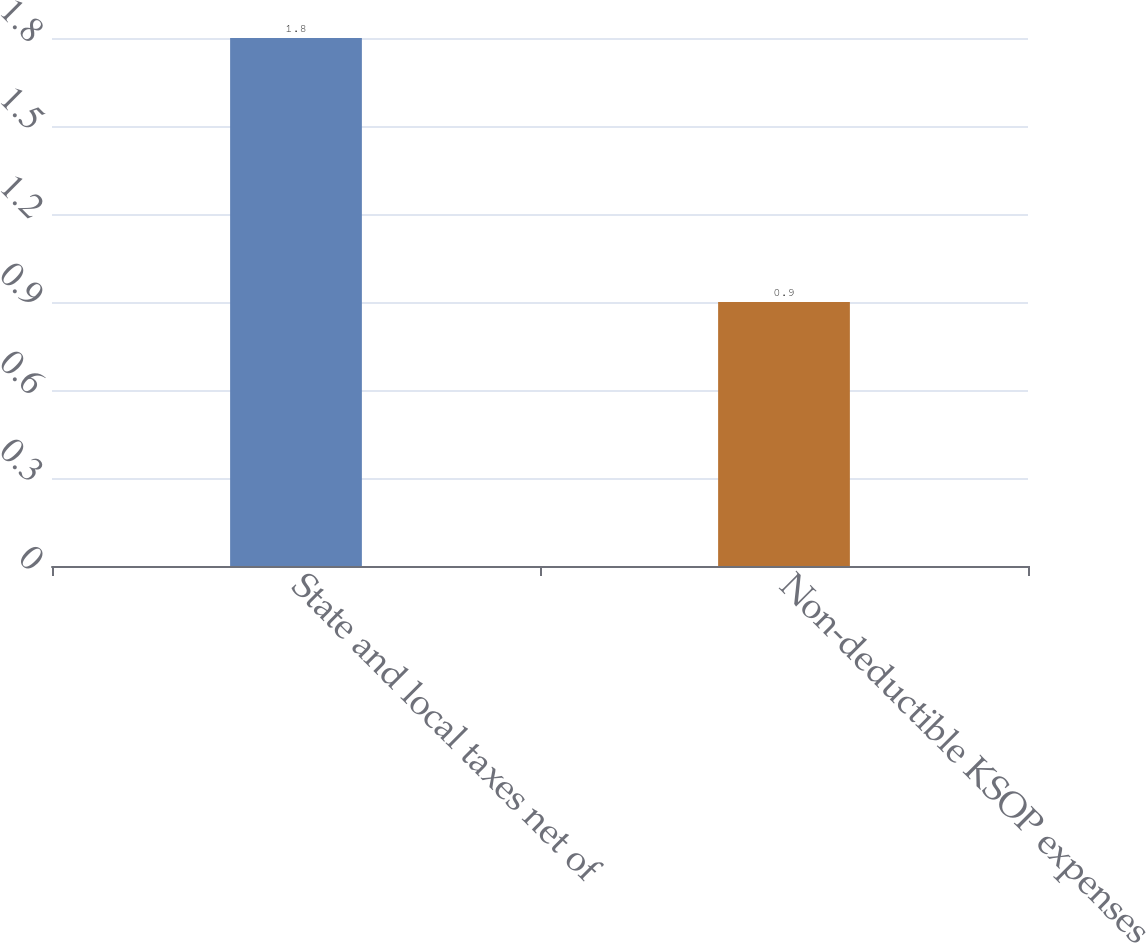Convert chart. <chart><loc_0><loc_0><loc_500><loc_500><bar_chart><fcel>State and local taxes net of<fcel>Non-deductible KSOP expenses<nl><fcel>1.8<fcel>0.9<nl></chart> 